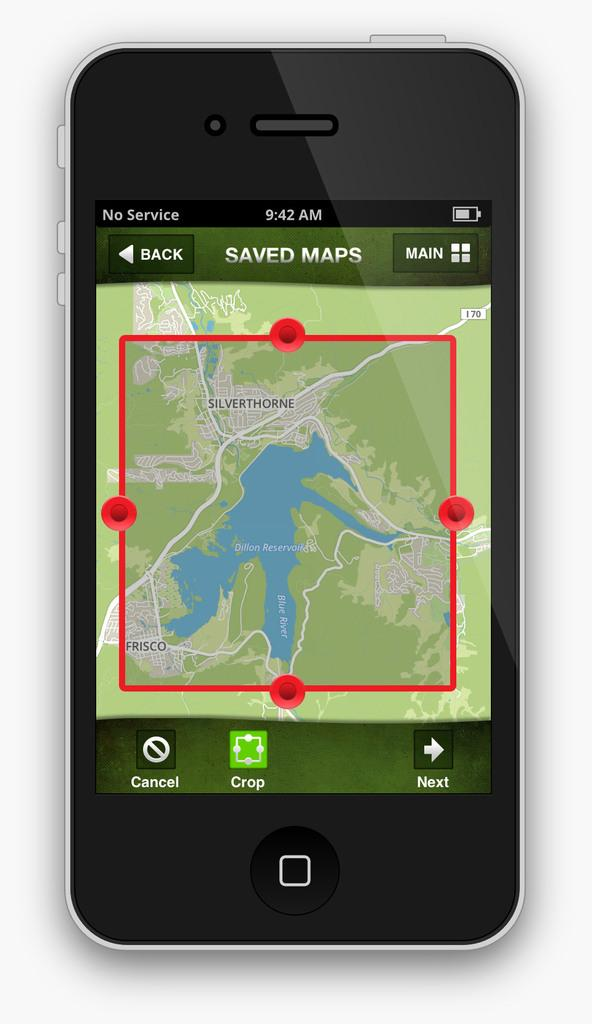<image>
Present a compact description of the photo's key features. A phone has a red box in a GPS that is around the town Silverthorne. 